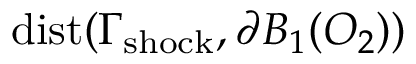Convert formula to latex. <formula><loc_0><loc_0><loc_500><loc_500>d i s t ( \Gamma _ { s h o c k } , \partial B _ { 1 } ( O _ { 2 } ) )</formula> 